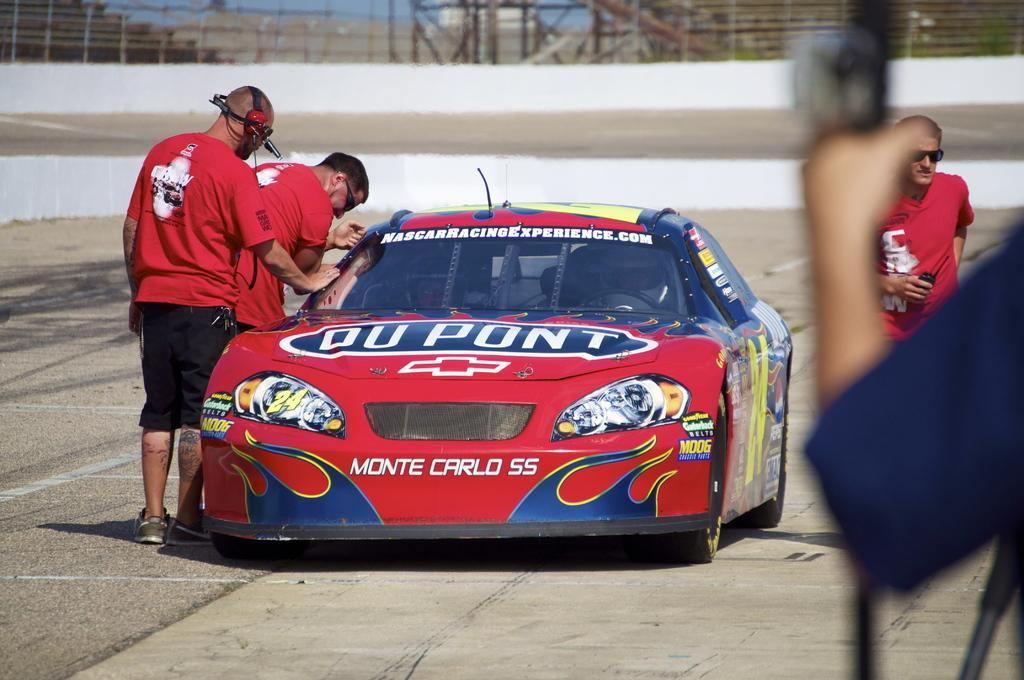Could you give a brief overview of what you see in this image? This picture is clicked outside. On the left there are two persons wearing red color t-shirts and standing on the ground. In the center there is a red color parked on the ground. On the right we can see the two persons. In the background we can see the metal rods, building and the sky. 